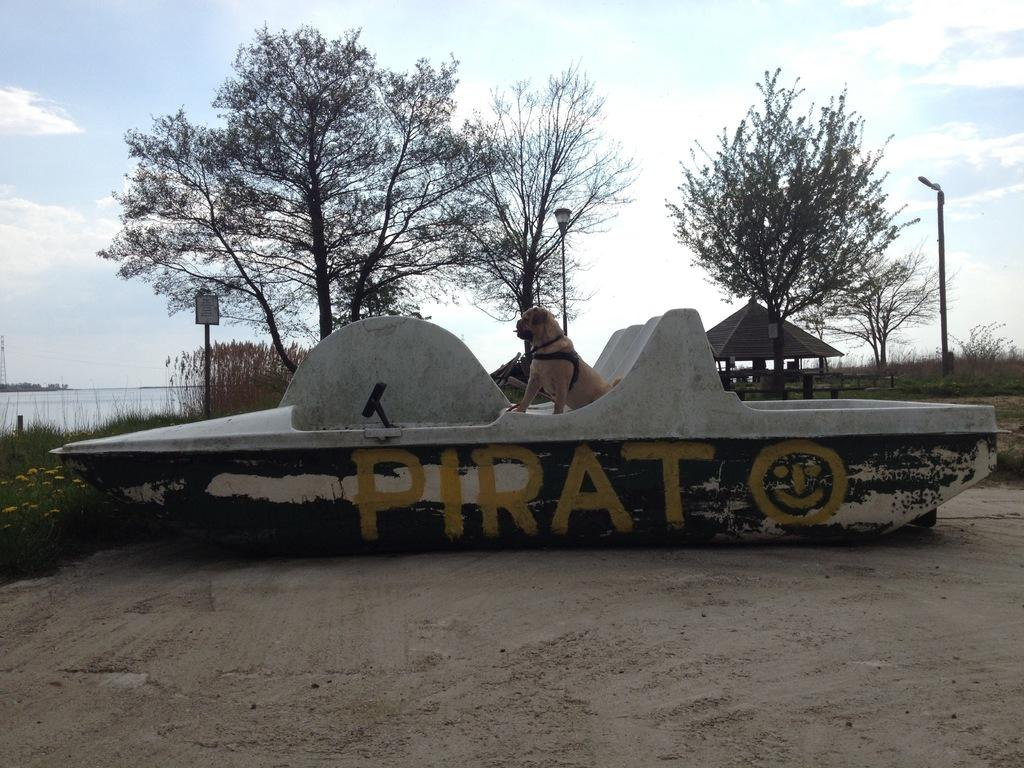What animal can be seen in the image? There is a dog in the image. Where is the dog located? The dog is sitting in a boat. What is the boat's location in the image? The boat is on the sand. What type of vegetation is present in the left corner of the image? There are plants in the left corner of the image. What can be seen in the background of the image? There are trees and poles in the background of the image. What type of detail can be seen on the rat's tail in the image? There is no rat present in the image, so there is no detail to observe on its tail. 